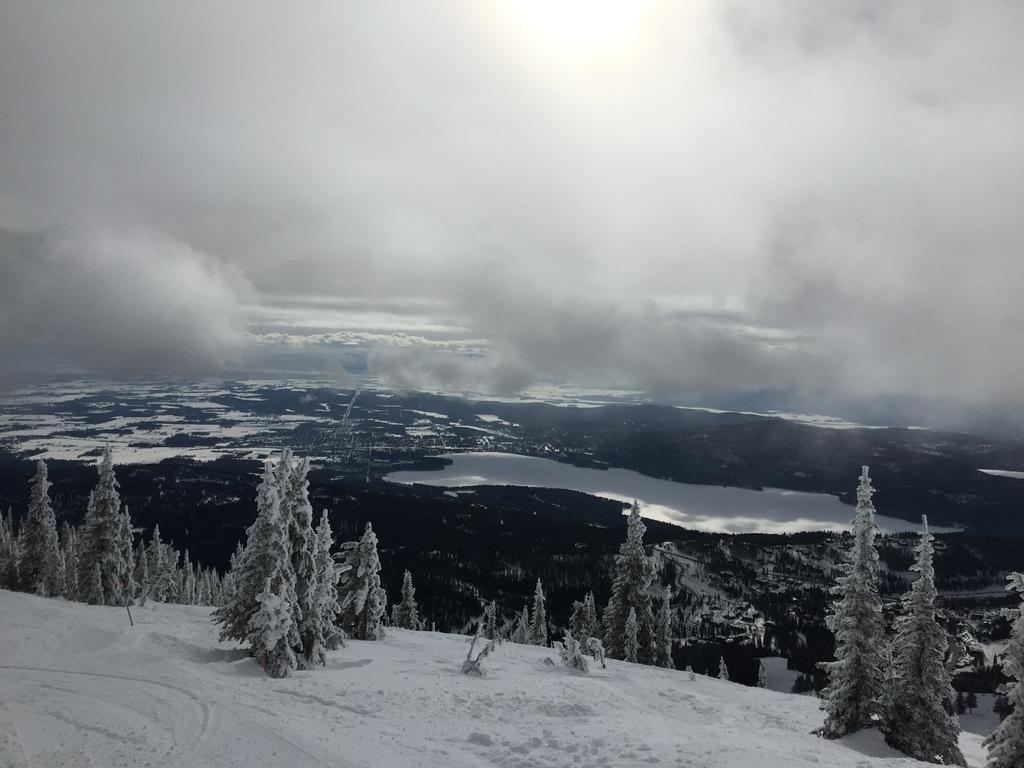Please provide a concise description of this image. In this picture I can see there is a mountain and it is covered with snow and there are trees and there is a lake in the backdrop and there are trees covered with snow and the sky is cloudy and sunny. 